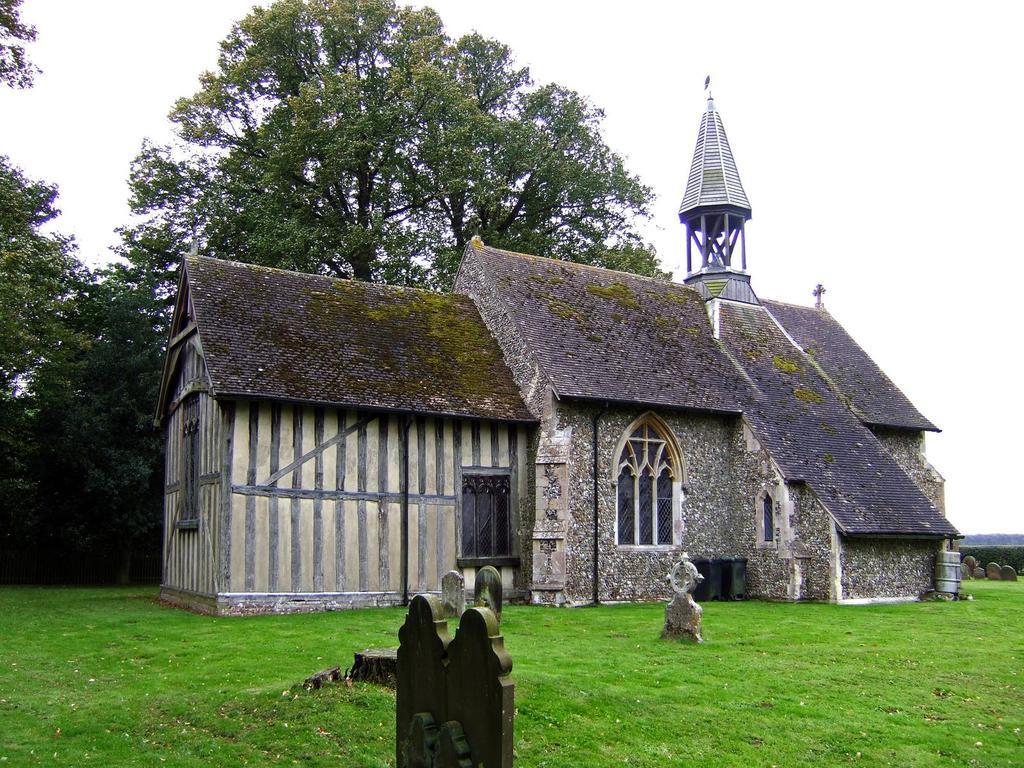Describe this image in one or two sentences. In the foreground I can see grass and a house. In the background I can see trees and the sky. This image is taken during a day. 